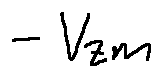Convert formula to latex. <formula><loc_0><loc_0><loc_500><loc_500>- V z m</formula> 